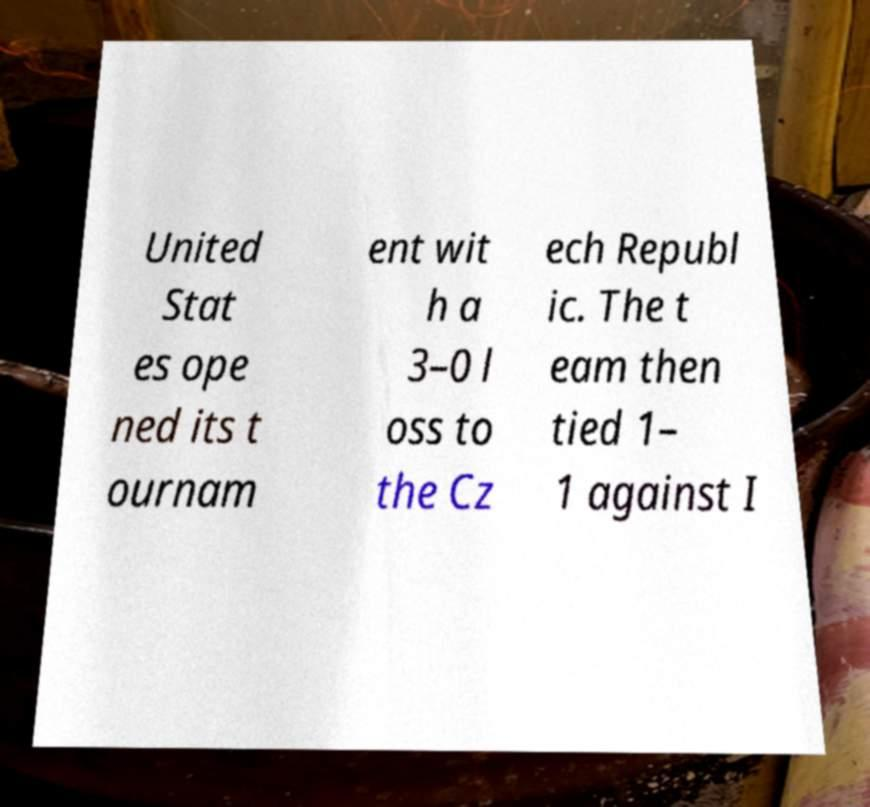Can you accurately transcribe the text from the provided image for me? United Stat es ope ned its t ournam ent wit h a 3–0 l oss to the Cz ech Republ ic. The t eam then tied 1– 1 against I 